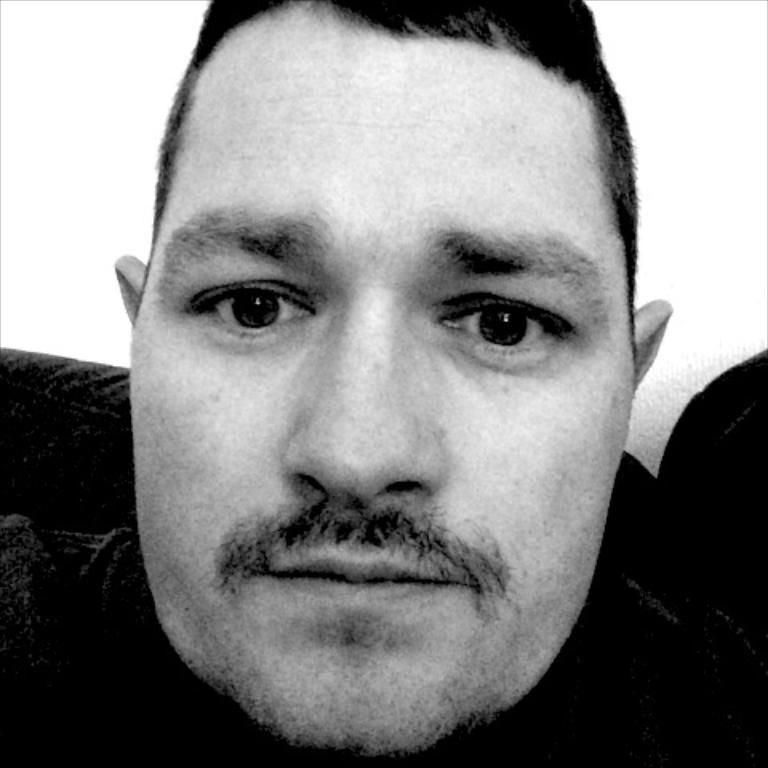What is the main subject of the image? There is a person's face in the image. Can you describe anything else visible in the image? There is an object in the background of the image. What type of camp can be seen in the background of the image? There is no camp visible in the image; it only features a person's face and an object in the background. Can you provide an example of the person's face in the image? The person's face is already visible in the image, so there is no need to provide an example. 